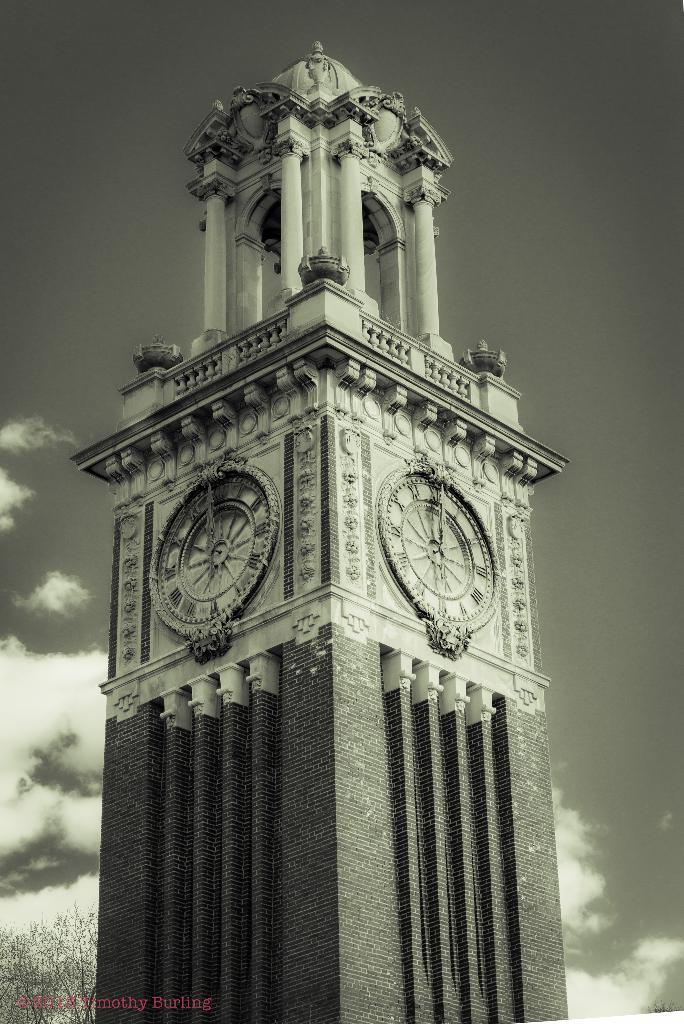What is the main structure in the image? There is a clock tower in the image. What is visible at the top of the image? The sky is visible at the top of the image. What color scheme is used in the image? The image is in black and white color. How many pairs of shoes can be seen on the clock tower in the image? There are no shoes present on the clock tower in the image. What type of mice can be seen running around the clock tower in the image? There are no mice present in the image. 